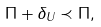<formula> <loc_0><loc_0><loc_500><loc_500>\Pi + \delta _ { U } \prec \Pi ,</formula> 